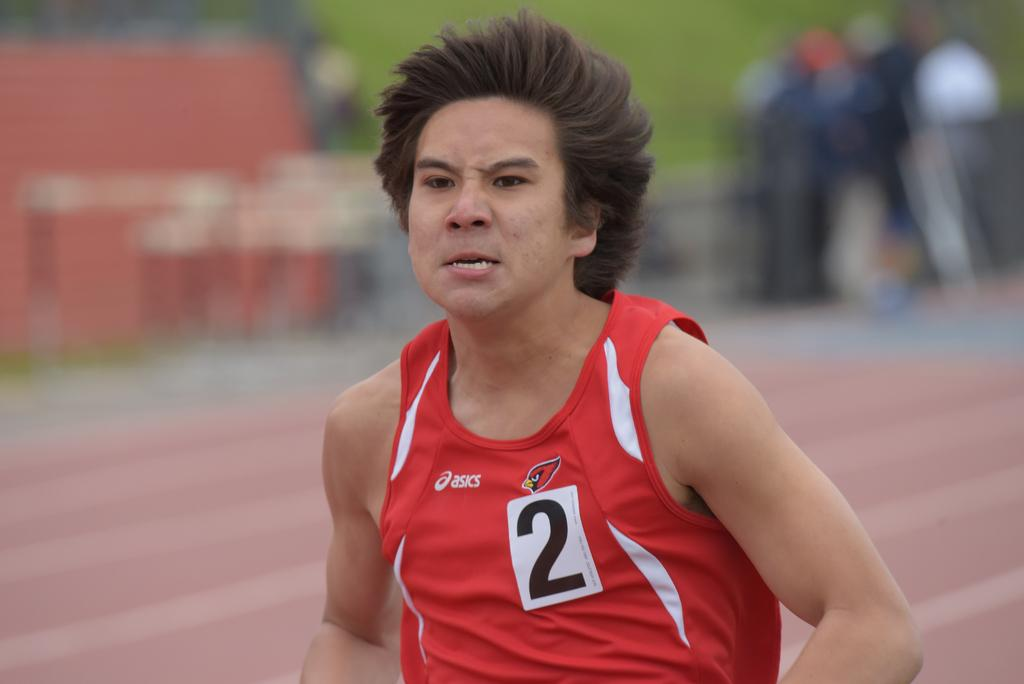Provide a one-sentence caption for the provided image. A man is running and has the number 2 on his shirt. 